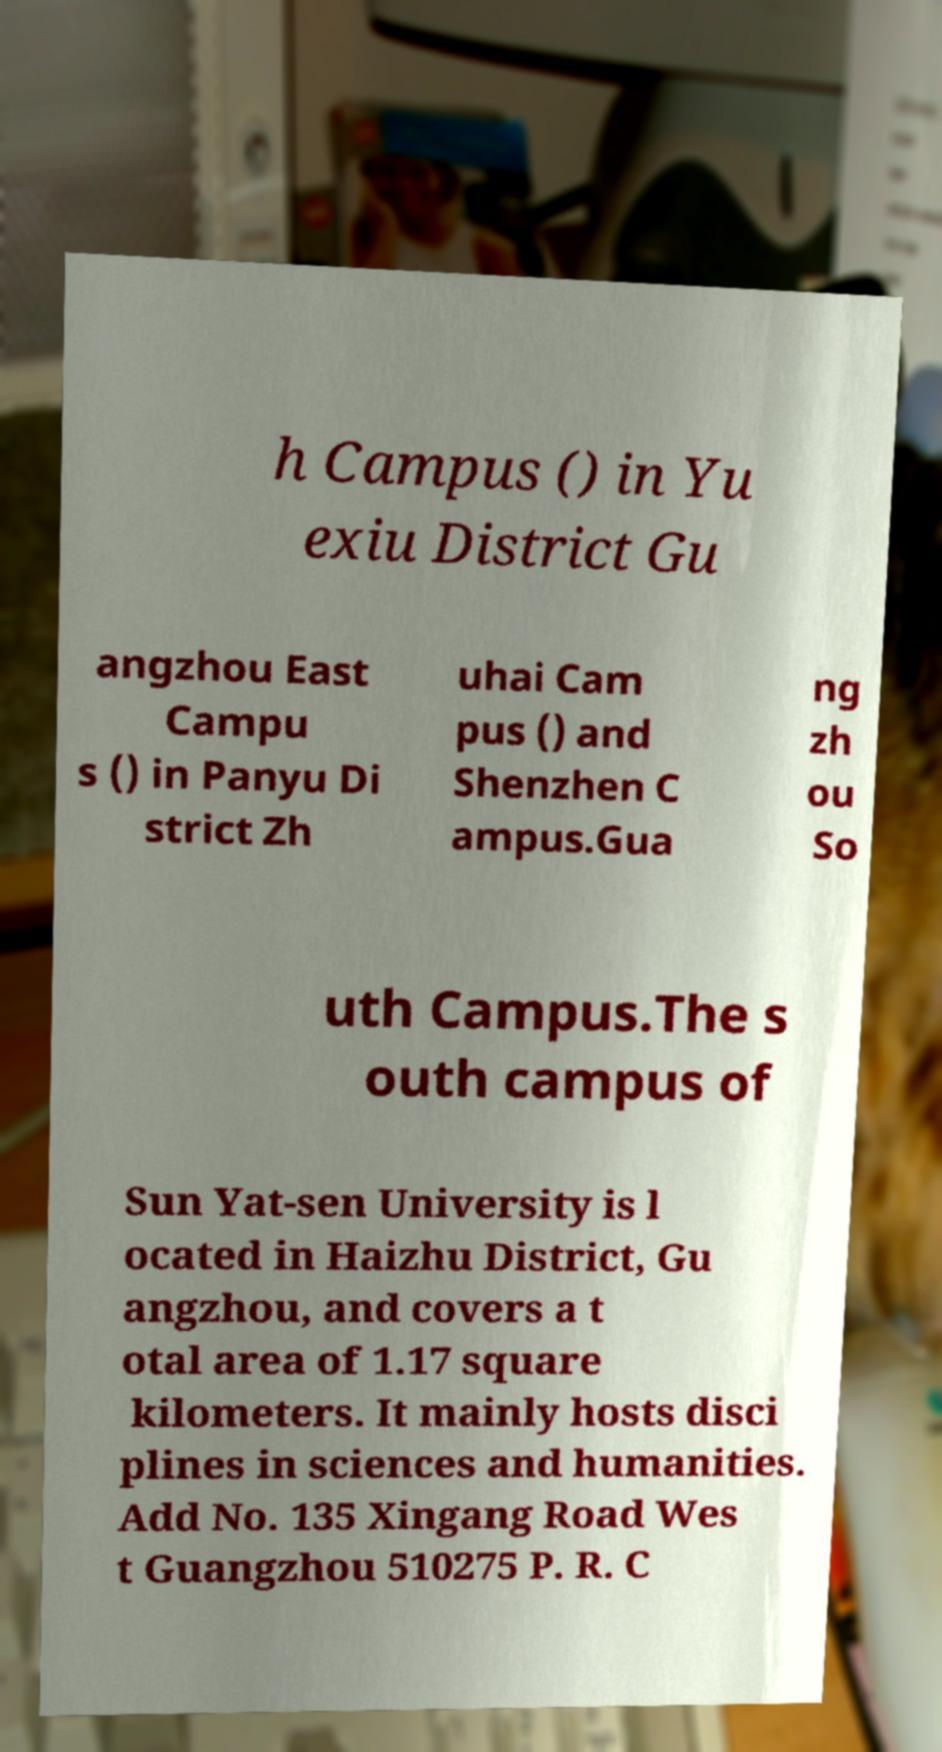Can you read and provide the text displayed in the image?This photo seems to have some interesting text. Can you extract and type it out for me? h Campus () in Yu exiu District Gu angzhou East Campu s () in Panyu Di strict Zh uhai Cam pus () and Shenzhen C ampus.Gua ng zh ou So uth Campus.The s outh campus of Sun Yat-sen University is l ocated in Haizhu District, Gu angzhou, and covers a t otal area of 1.17 square kilometers. It mainly hosts disci plines in sciences and humanities. Add No. 135 Xingang Road Wes t Guangzhou 510275 P. R. C 